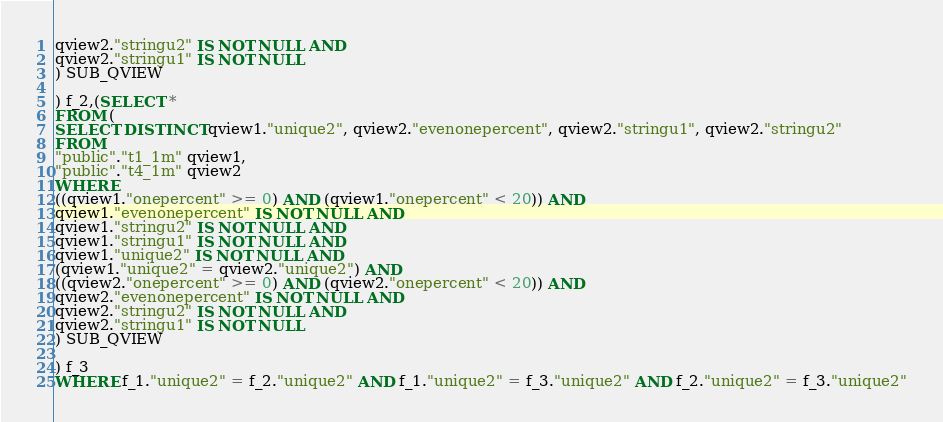Convert code to text. <code><loc_0><loc_0><loc_500><loc_500><_SQL_>qview2."stringu2" IS NOT NULL AND
qview2."stringu1" IS NOT NULL
) SUB_QVIEW

) f_2,(SELECT *
FROM (
SELECT DISTINCT qview1."unique2", qview2."evenonepercent", qview2."stringu1", qview2."stringu2"
FROM
"public"."t1_1m" qview1,
"public"."t4_1m" qview2
WHERE
((qview1."onepercent" >= 0) AND (qview1."onepercent" < 20)) AND
qview1."evenonepercent" IS NOT NULL AND
qview1."stringu2" IS NOT NULL AND
qview1."stringu1" IS NOT NULL AND
qview1."unique2" IS NOT NULL AND
(qview1."unique2" = qview2."unique2") AND
((qview2."onepercent" >= 0) AND (qview2."onepercent" < 20)) AND
qview2."evenonepercent" IS NOT NULL AND
qview2."stringu2" IS NOT NULL AND
qview2."stringu1" IS NOT NULL
) SUB_QVIEW

) f_3
WHERE f_1."unique2" = f_2."unique2" AND f_1."unique2" = f_3."unique2" AND f_2."unique2" = f_3."unique2"
</code> 